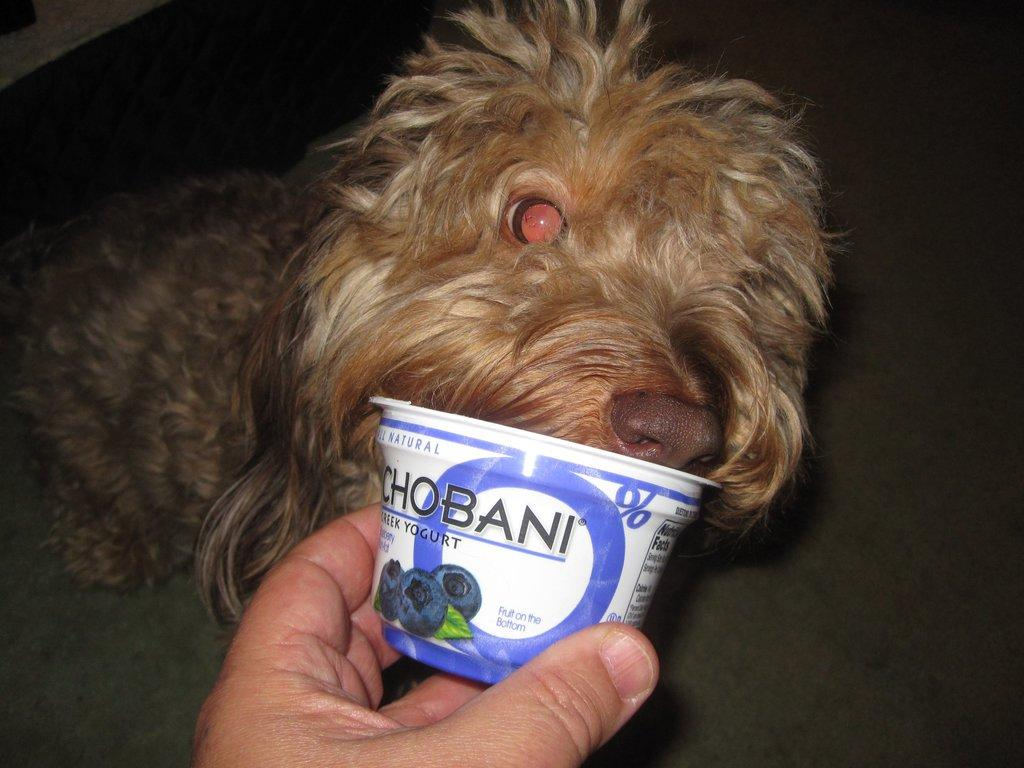What type of animal is in the image? There is an animal in the image, but the specific type cannot be determined from the provided facts. What is the person's hand holding in the image? A person's hand is holding an object in the image, but the specific object cannot be determined from the provided facts. What can be seen beneath the animal and person's hand in the image? The ground is visible in the image. How many ducks are visible in the image? There are no ducks present in the image. What is the person's elbow doing in the image? There is no mention of a person's elbow in the provided facts, so it cannot be determined from the image. 